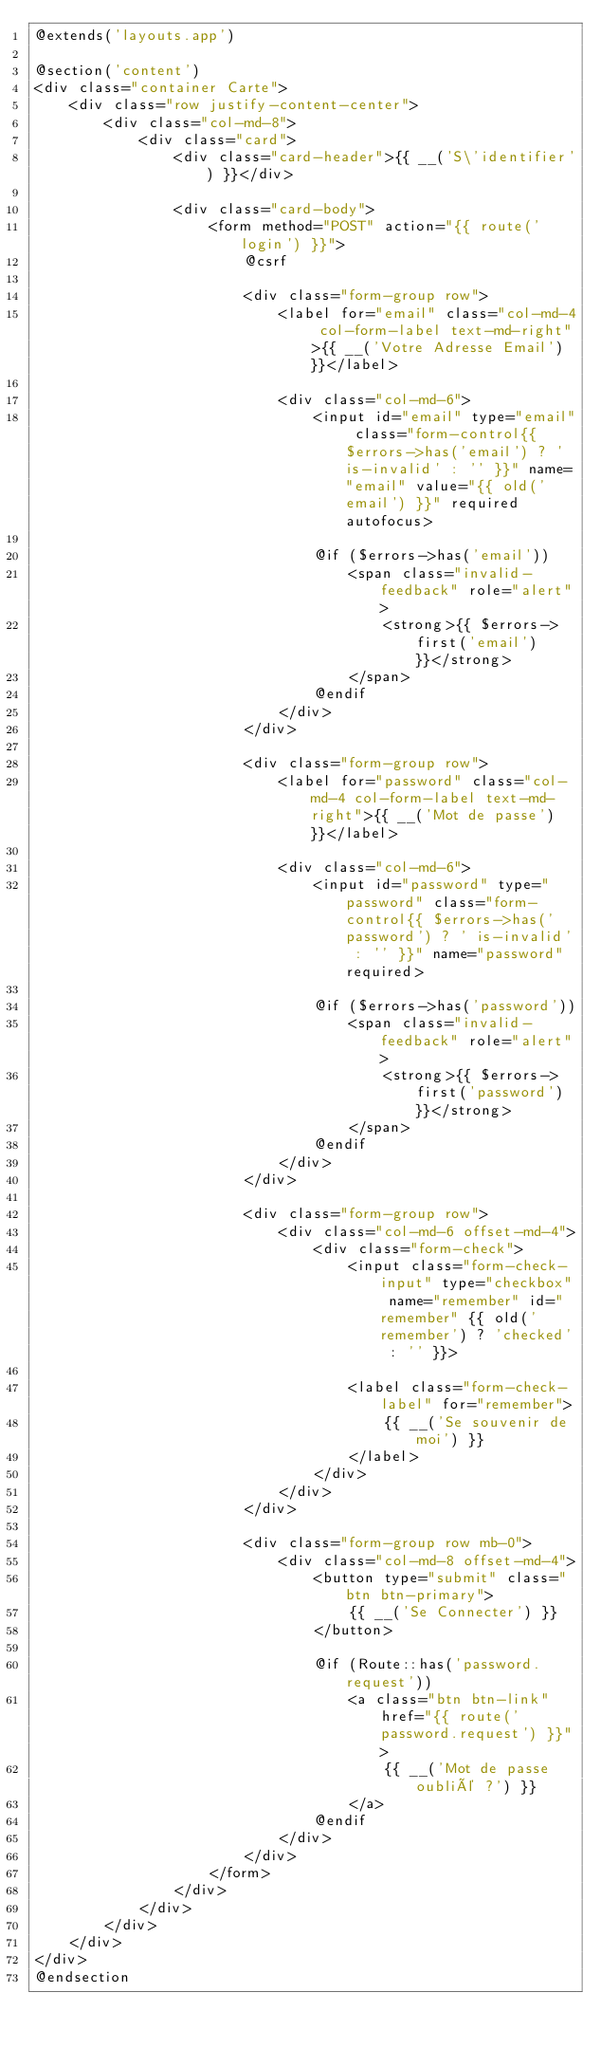<code> <loc_0><loc_0><loc_500><loc_500><_PHP_>@extends('layouts.app')

@section('content')
<div class="container Carte">
    <div class="row justify-content-center">
        <div class="col-md-8">
            <div class="card">
                <div class="card-header">{{ __('S\'identifier') }}</div>

                <div class="card-body">
                    <form method="POST" action="{{ route('login') }}">
                        @csrf

                        <div class="form-group row">
                            <label for="email" class="col-md-4 col-form-label text-md-right">{{ __('Votre Adresse Email') }}</label>

                            <div class="col-md-6">
                                <input id="email" type="email" class="form-control{{ $errors->has('email') ? ' is-invalid' : '' }}" name="email" value="{{ old('email') }}" required autofocus>

                                @if ($errors->has('email'))
                                    <span class="invalid-feedback" role="alert">
                                        <strong>{{ $errors->first('email') }}</strong>
                                    </span>
                                @endif
                            </div>
                        </div>

                        <div class="form-group row">
                            <label for="password" class="col-md-4 col-form-label text-md-right">{{ __('Mot de passe') }}</label>

                            <div class="col-md-6">
                                <input id="password" type="password" class="form-control{{ $errors->has('password') ? ' is-invalid' : '' }}" name="password" required>

                                @if ($errors->has('password'))
                                    <span class="invalid-feedback" role="alert">
                                        <strong>{{ $errors->first('password') }}</strong>
                                    </span>
                                @endif
                            </div>
                        </div>

                        <div class="form-group row">
                            <div class="col-md-6 offset-md-4">
                                <div class="form-check">
                                    <input class="form-check-input" type="checkbox" name="remember" id="remember" {{ old('remember') ? 'checked' : '' }}>

                                    <label class="form-check-label" for="remember">
                                        {{ __('Se souvenir de moi') }}
                                    </label>
                                </div>
                            </div>
                        </div>

                        <div class="form-group row mb-0">
                            <div class="col-md-8 offset-md-4">
                                <button type="submit" class="btn btn-primary">
                                    {{ __('Se Connecter') }}
                                </button>

                                @if (Route::has('password.request'))
                                    <a class="btn btn-link" href="{{ route('password.request') }}">
                                        {{ __('Mot de passe oublié ?') }}
                                    </a>
                                @endif
                            </div>
                        </div>
                    </form>
                </div>
            </div>
        </div>
    </div>
</div>
@endsection
</code> 